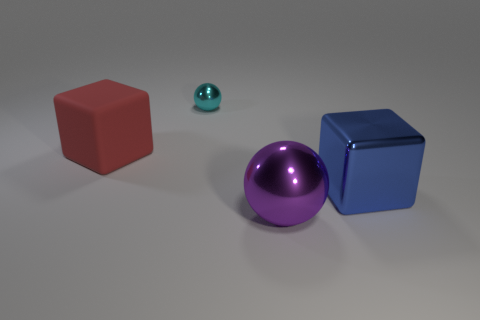Are the objects casting shadows and what does this tell us about the light source? Yes, each object is casting a soft shadow, indicating that there is a light source in the scene, likely positioned to the upper left, given the shadows' direction. This suggests a single, diffuse light source, simulating an overcast sky or a softbox used in photography. 